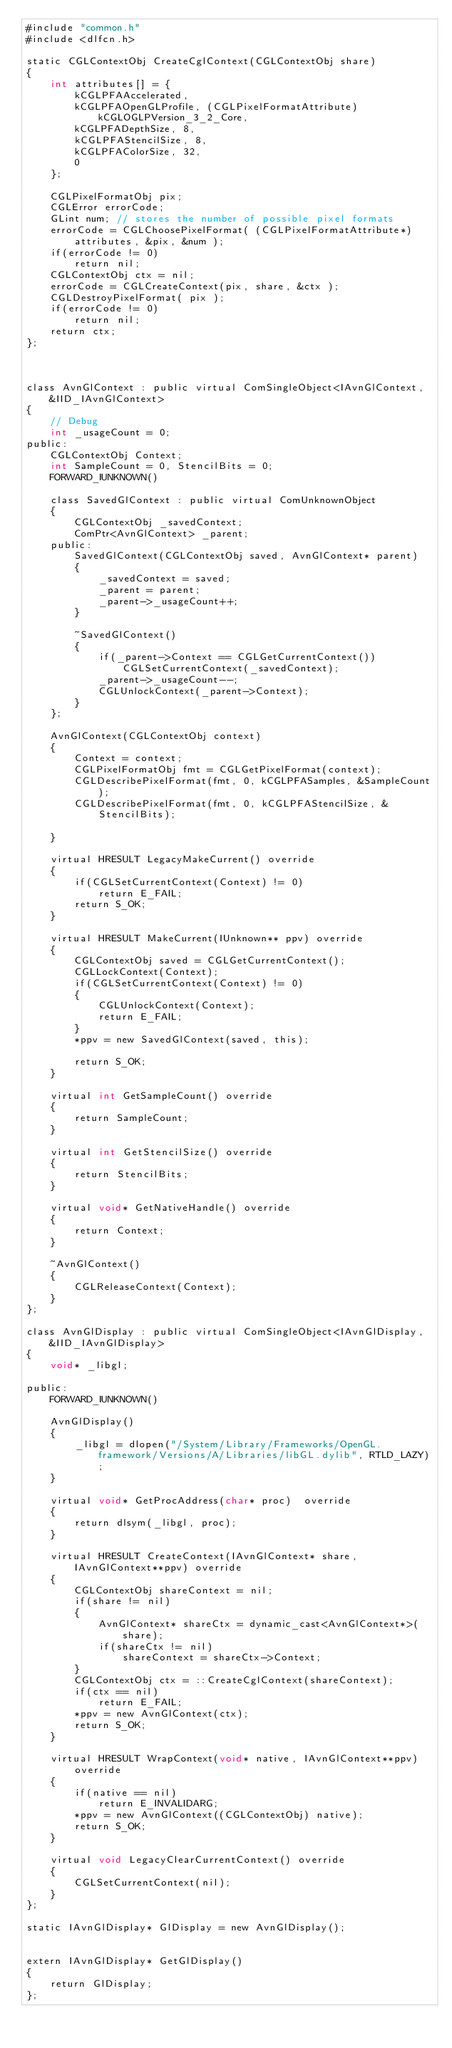Convert code to text. <code><loc_0><loc_0><loc_500><loc_500><_ObjectiveC_>#include "common.h"
#include <dlfcn.h>

static CGLContextObj CreateCglContext(CGLContextObj share)
{
    int attributes[] = {
        kCGLPFAAccelerated,
        kCGLPFAOpenGLProfile, (CGLPixelFormatAttribute)kCGLOGLPVersion_3_2_Core,
        kCGLPFADepthSize, 8,
        kCGLPFAStencilSize, 8,
        kCGLPFAColorSize, 32,
        0
    };
    
    CGLPixelFormatObj pix;
    CGLError errorCode;
    GLint num; // stores the number of possible pixel formats
    errorCode = CGLChoosePixelFormat( (CGLPixelFormatAttribute*)attributes, &pix, &num );
    if(errorCode != 0)
        return nil;
    CGLContextObj ctx = nil;
    errorCode = CGLCreateContext(pix, share, &ctx );
    CGLDestroyPixelFormat( pix );
    if(errorCode != 0)
        return nil;
    return ctx;
};



class AvnGlContext : public virtual ComSingleObject<IAvnGlContext, &IID_IAvnGlContext>
{
    // Debug
    int _usageCount = 0;
public:
    CGLContextObj Context;
    int SampleCount = 0, StencilBits = 0;
    FORWARD_IUNKNOWN()
    
    class SavedGlContext : public virtual ComUnknownObject
    {
        CGLContextObj _savedContext;
        ComPtr<AvnGlContext> _parent;
    public:
        SavedGlContext(CGLContextObj saved, AvnGlContext* parent)
        {
            _savedContext = saved;
            _parent = parent;
            _parent->_usageCount++;
        }
        
        ~SavedGlContext()
        {
            if(_parent->Context == CGLGetCurrentContext())
                CGLSetCurrentContext(_savedContext);
            _parent->_usageCount--;
            CGLUnlockContext(_parent->Context);
        }
    };
    
    AvnGlContext(CGLContextObj context)
    {
        Context = context;
        CGLPixelFormatObj fmt = CGLGetPixelFormat(context);
        CGLDescribePixelFormat(fmt, 0, kCGLPFASamples, &SampleCount);
        CGLDescribePixelFormat(fmt, 0, kCGLPFAStencilSize, &StencilBits);
        
    }
    
    virtual HRESULT LegacyMakeCurrent() override
    {
        if(CGLSetCurrentContext(Context) != 0)
            return E_FAIL;
        return S_OK;
    }
    
    virtual HRESULT MakeCurrent(IUnknown** ppv) override
    {
        CGLContextObj saved = CGLGetCurrentContext();
        CGLLockContext(Context);
        if(CGLSetCurrentContext(Context) != 0)
        {
            CGLUnlockContext(Context);
            return E_FAIL;
        }
        *ppv = new SavedGlContext(saved, this);
        
        return S_OK;
    }
    
    virtual int GetSampleCount() override
    {
        return SampleCount;
    }
    
    virtual int GetStencilSize() override
    {
        return StencilBits;
    }
    
    virtual void* GetNativeHandle() override
    {
        return Context;
    }
    
    ~AvnGlContext()
    {
        CGLReleaseContext(Context);
    }
};

class AvnGlDisplay : public virtual ComSingleObject<IAvnGlDisplay, &IID_IAvnGlDisplay>
{
    void* _libgl;
    
public:
    FORWARD_IUNKNOWN()
    
    AvnGlDisplay()
    {
        _libgl = dlopen("/System/Library/Frameworks/OpenGL.framework/Versions/A/Libraries/libGL.dylib", RTLD_LAZY);
    }
    
    virtual void* GetProcAddress(char* proc)  override
    {
        return dlsym(_libgl, proc);
    }
    
    virtual HRESULT CreateContext(IAvnGlContext* share, IAvnGlContext**ppv) override
    {
        CGLContextObj shareContext = nil;
        if(share != nil)
        {
            AvnGlContext* shareCtx = dynamic_cast<AvnGlContext*>(share);
            if(shareCtx != nil)
                shareContext = shareCtx->Context;
        }
        CGLContextObj ctx = ::CreateCglContext(shareContext);
        if(ctx == nil)
            return E_FAIL;
        *ppv = new AvnGlContext(ctx);
        return S_OK;
    }
    
    virtual HRESULT WrapContext(void* native, IAvnGlContext**ppv) override
    {
        if(native == nil)
            return E_INVALIDARG;
        *ppv = new AvnGlContext((CGLContextObj) native);
        return S_OK;
    }
    
    virtual void LegacyClearCurrentContext() override
    {
        CGLSetCurrentContext(nil);
    }
};

static IAvnGlDisplay* GlDisplay = new AvnGlDisplay();


extern IAvnGlDisplay* GetGlDisplay()
{
    return GlDisplay;
};

</code> 